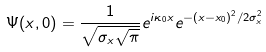Convert formula to latex. <formula><loc_0><loc_0><loc_500><loc_500>\Psi ( x , 0 ) = \frac { 1 } { \sqrt { \sigma _ { x } \sqrt { \pi } } } e ^ { i \kappa _ { 0 } x } e ^ { - ( x - x _ { 0 } ) ^ { 2 } / 2 \sigma _ { x } ^ { 2 } }</formula> 